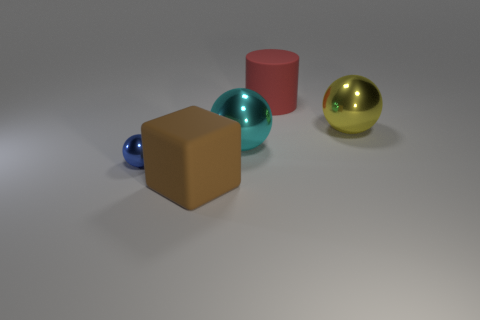Is there a big cyan metal ball that is in front of the big sphere that is on the left side of the yellow thing that is behind the big cyan metallic object?
Give a very brief answer. No. The cube that is the same material as the large cylinder is what color?
Ensure brevity in your answer.  Brown. Do the large rubber thing that is behind the cyan object and the large block have the same color?
Give a very brief answer. No. What number of cubes are blue metal things or matte things?
Offer a terse response. 1. There is a matte object behind the sphere behind the big metal sphere that is in front of the big yellow metallic thing; what size is it?
Keep it short and to the point. Large. There is a cyan object that is the same size as the cube; what is its shape?
Offer a very short reply. Sphere. What is the shape of the yellow metallic object?
Offer a very short reply. Sphere. Is the material of the big ball right of the large cylinder the same as the cylinder?
Your response must be concise. No. There is a rubber thing to the left of the rubber thing that is on the right side of the large brown object; what is its size?
Give a very brief answer. Large. The big thing that is both to the left of the red rubber cylinder and behind the large block is what color?
Your response must be concise. Cyan. 